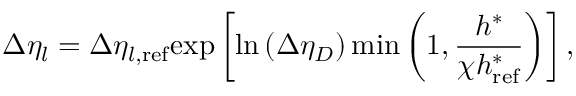<formula> <loc_0><loc_0><loc_500><loc_500>\Delta \eta _ { l } = \Delta \eta _ { l , r e f } e x p \left [ \ln \left ( \Delta \eta _ { D } \right ) \min \left ( 1 , \frac { h ^ { * } } { \chi h _ { r e f } ^ { * } } \right ) \right ] ,</formula> 